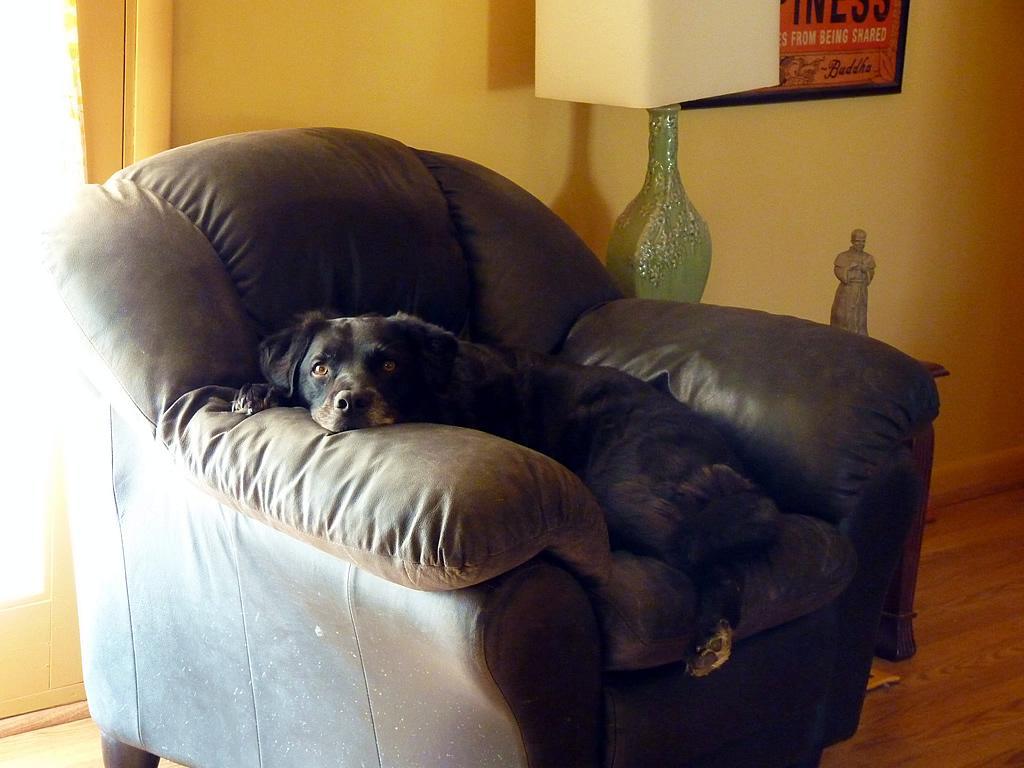Please provide a concise description of this image. This image consists of a sofa which is in black color and a dog is on the Sofa it is also in black colour. There is a lamp on the top and there is a photo frame on the wall. 